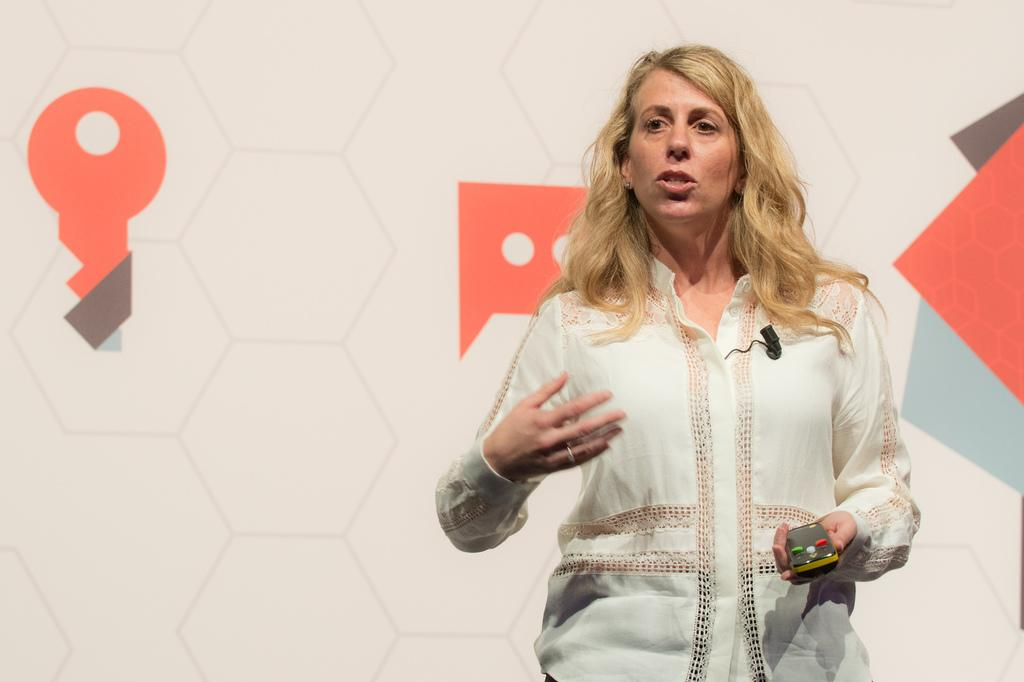What is the main subject of the image? There is a woman in the image. What is the woman doing in the image? The woman is standing and speaking. What is the woman holding in her hand? The woman is holding an object in her hand. What can be seen in the background of the image? There is a board with images in the background of the image. Can you tell me how many zebras are visible in the image? There are no zebras present in the image. What is the woman learning in the image? The provided facts do not mention the woman learning anything in the image. 